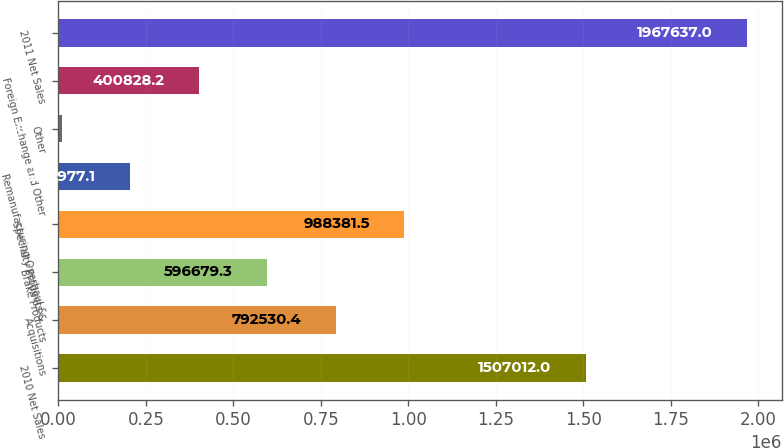Convert chart to OTSL. <chart><loc_0><loc_0><loc_500><loc_500><bar_chart><fcel>2010 Net Sales<fcel>Acquisitions<fcel>Brake Products<fcel>Specialty Products &<fcel>Remanufacturing Overhaul &<fcel>Other<fcel>Foreign Exchange and Other<fcel>2011 Net Sales<nl><fcel>1.50701e+06<fcel>792530<fcel>596679<fcel>988382<fcel>204977<fcel>9126<fcel>400828<fcel>1.96764e+06<nl></chart> 